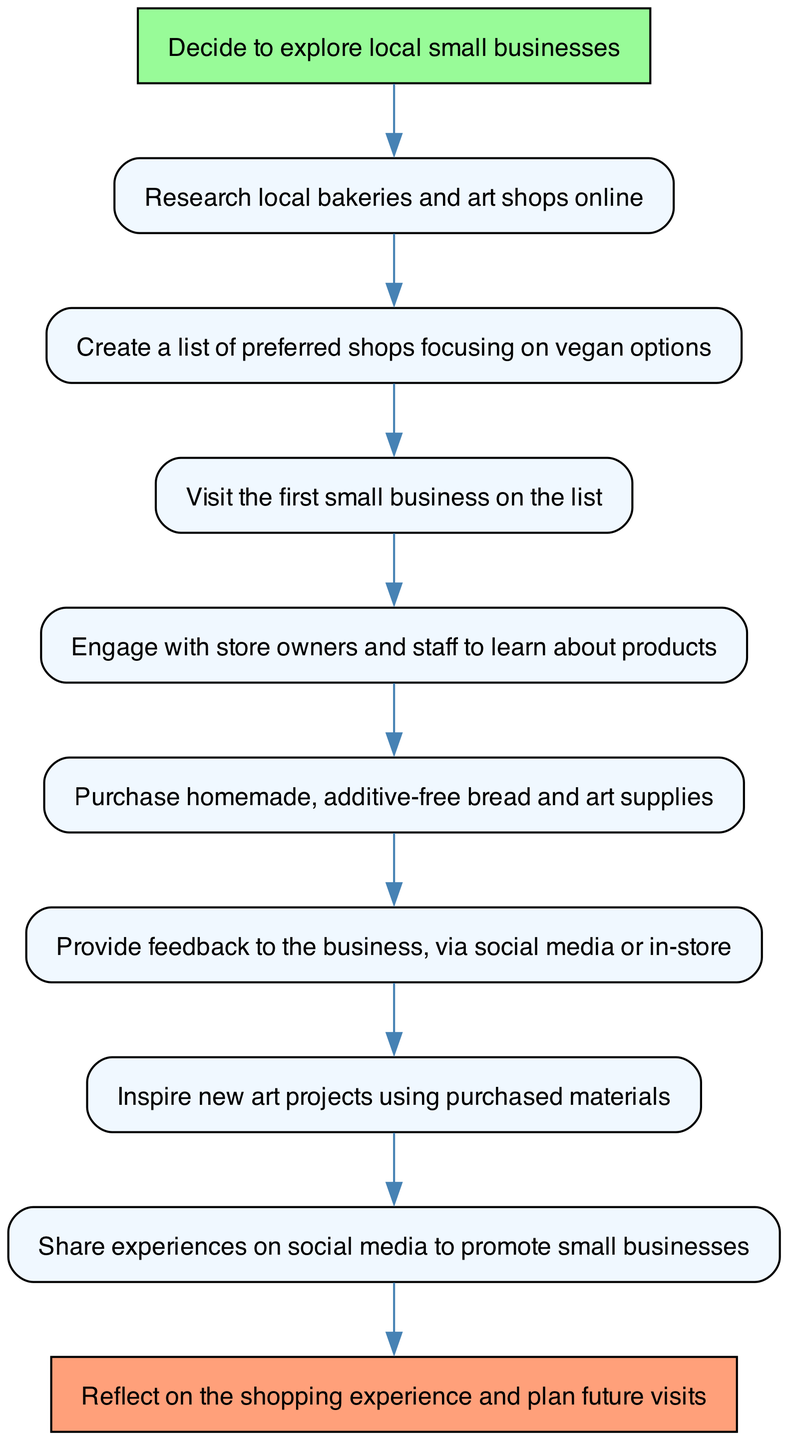What is the first node in the flow chart? The first node is labeled "Decide to explore local small businesses." This can be identified as it is the starting point, marked as the initial action in the customer journey.
Answer: Decide to explore local small businesses How many nodes are there in total? By counting all the individual actions represented in the diagram, we find there are ten distinct nodes listed.
Answer: 10 What happens after "Visit the first small business on the list"? The subsequent action after visiting a small business is "Engage with store owners and staff to learn about products." This shows the continuation of the customer journey from a visit to interaction.
Answer: Engage with store owners and staff to learn about products Which action follows "Provide feedback to the business"? After providing feedback to the business, the next action is "Inspire new art projects using purchased materials." This indicates a progression from feedback to creativity based on the shopping experience.
Answer: Inspire new art projects using purchased materials What is the relationship between "Share experiences on social media" and "Purchase homemade, additive-free bread and art supplies"? "Share experiences on social media" follows "Provide feedback to the business," which means that sharing takes place after making a purchase, indicating it is a resultant action based on the experience itself.
Answer: Share experiences on social media How does the flow of the diagram indicate the purpose of visiting local small businesses? The flow illustrates that the purpose extends beyond mere purchases; it emphasizes interaction, feedback, and sharing experiences that can foster community and inspiration. This is deduced by observing the sequential steps from the initial decision to the reflective end.
Answer: Community and inspiration What color represents the start and end nodes in the diagram? The start node is highlighted with a greenish color (#98FB98), while the end node features a light coral color (#FFA07A), which allows for easy identification of the flow's beginning and conclusion.
Answer: Greenish and light coral What is the last action in the customer journey flow? The last action in the flow chart is "Reflect on the shopping experience and plan future visits," summarizing the overall journey and encouraging repetition.
Answer: Reflect on the shopping experience and plan future visits 